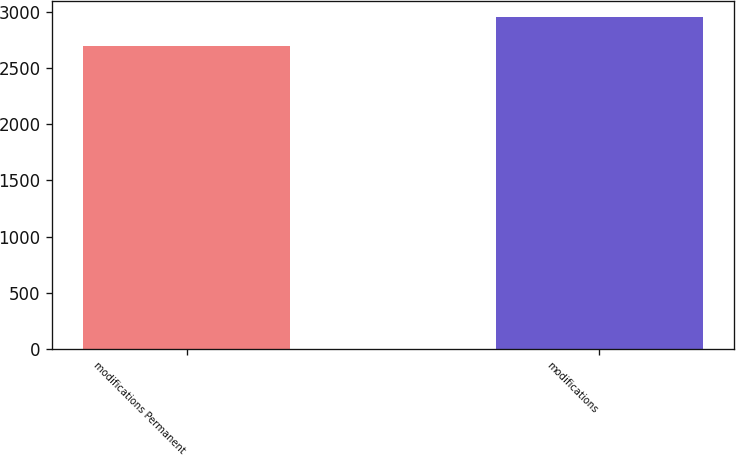Convert chart. <chart><loc_0><loc_0><loc_500><loc_500><bar_chart><fcel>modifications Permanent<fcel>modifications<nl><fcel>2693<fcel>2951<nl></chart> 